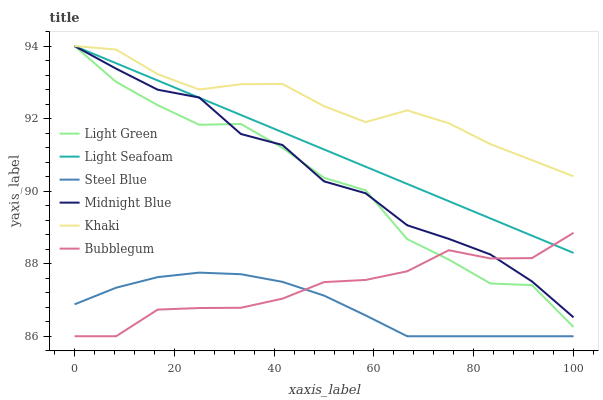Does Steel Blue have the minimum area under the curve?
Answer yes or no. Yes. Does Khaki have the maximum area under the curve?
Answer yes or no. Yes. Does Midnight Blue have the minimum area under the curve?
Answer yes or no. No. Does Midnight Blue have the maximum area under the curve?
Answer yes or no. No. Is Light Seafoam the smoothest?
Answer yes or no. Yes. Is Light Green the roughest?
Answer yes or no. Yes. Is Midnight Blue the smoothest?
Answer yes or no. No. Is Midnight Blue the roughest?
Answer yes or no. No. Does Steel Blue have the lowest value?
Answer yes or no. Yes. Does Midnight Blue have the lowest value?
Answer yes or no. No. Does Light Seafoam have the highest value?
Answer yes or no. Yes. Does Steel Blue have the highest value?
Answer yes or no. No. Is Steel Blue less than Midnight Blue?
Answer yes or no. Yes. Is Khaki greater than Bubblegum?
Answer yes or no. Yes. Does Midnight Blue intersect Bubblegum?
Answer yes or no. Yes. Is Midnight Blue less than Bubblegum?
Answer yes or no. No. Is Midnight Blue greater than Bubblegum?
Answer yes or no. No. Does Steel Blue intersect Midnight Blue?
Answer yes or no. No. 